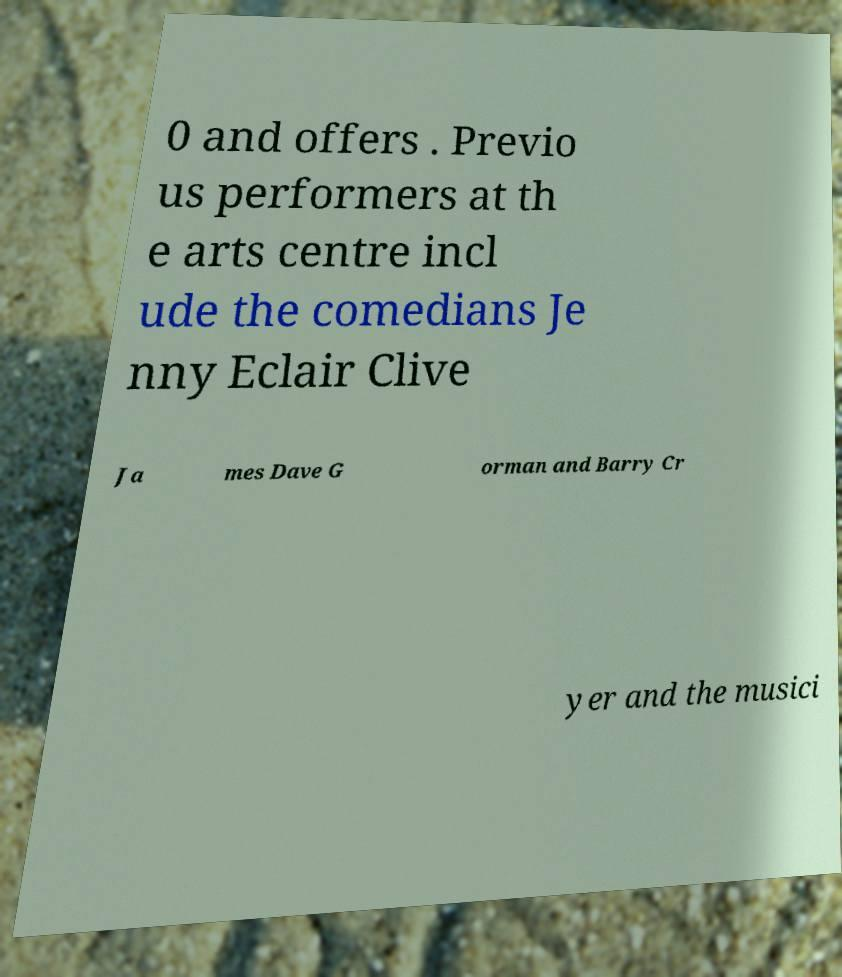Could you extract and type out the text from this image? 0 and offers . Previo us performers at th e arts centre incl ude the comedians Je nny Eclair Clive Ja mes Dave G orman and Barry Cr yer and the musici 